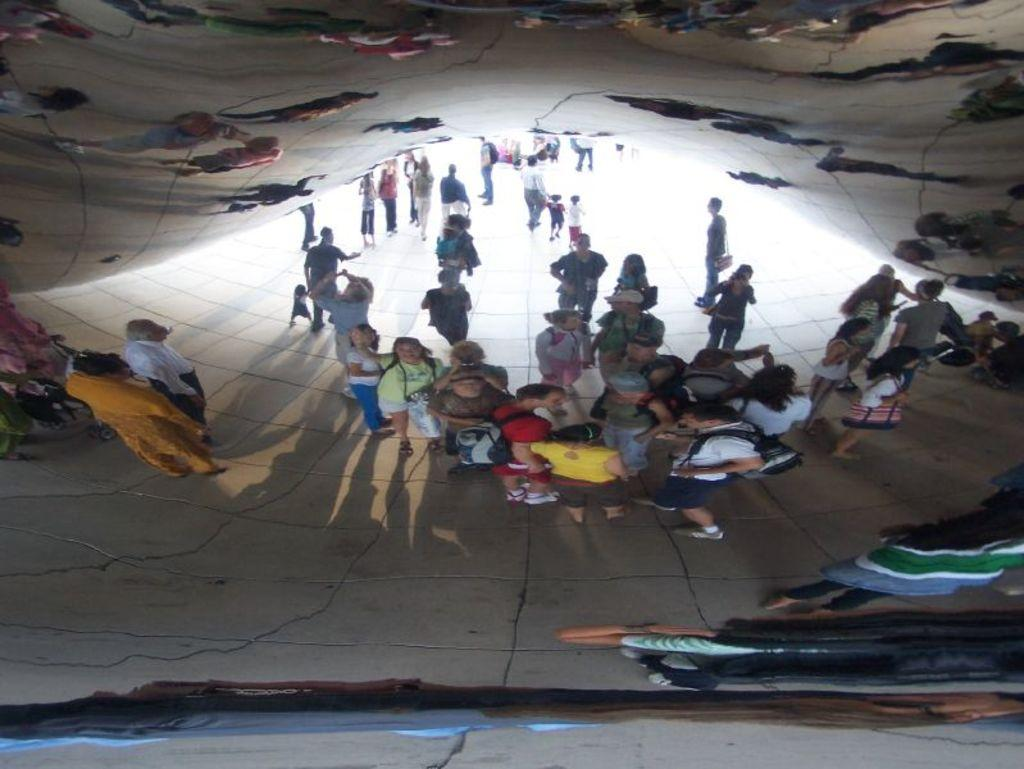What can be seen in the image due to the reflection? There is a reflection of people in the image. On what surface is the reflection visible? The reflection is on a glass surface. How many toes are visible in the image? There is no mention of toes or feet in the image, so it is not possible to determine how many toes are visible. 